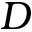<formula> <loc_0><loc_0><loc_500><loc_500>D</formula> 